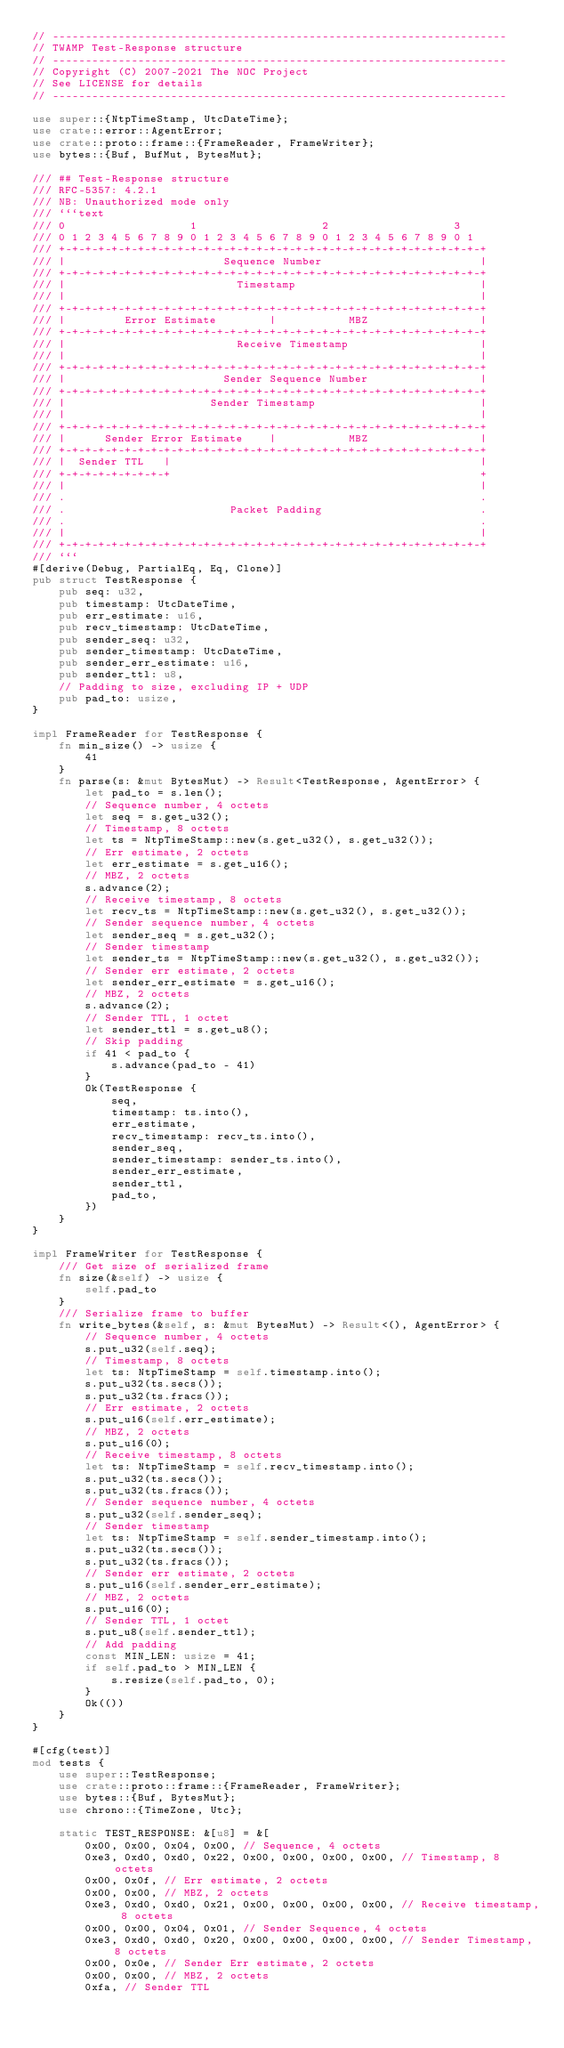Convert code to text. <code><loc_0><loc_0><loc_500><loc_500><_Rust_>// ---------------------------------------------------------------------
// TWAMP Test-Response structure
// ---------------------------------------------------------------------
// Copyright (C) 2007-2021 The NOC Project
// See LICENSE for details
// ---------------------------------------------------------------------

use super::{NtpTimeStamp, UtcDateTime};
use crate::error::AgentError;
use crate::proto::frame::{FrameReader, FrameWriter};
use bytes::{Buf, BufMut, BytesMut};

/// ## Test-Response structure
/// RFC-5357: 4.2.1
/// NB: Unauthorized mode only
/// ```text
/// 0                   1                   2                   3
/// 0 1 2 3 4 5 6 7 8 9 0 1 2 3 4 5 6 7 8 9 0 1 2 3 4 5 6 7 8 9 0 1
/// +-+-+-+-+-+-+-+-+-+-+-+-+-+-+-+-+-+-+-+-+-+-+-+-+-+-+-+-+-+-+-+-+
/// |                        Sequence Number                        |
/// +-+-+-+-+-+-+-+-+-+-+-+-+-+-+-+-+-+-+-+-+-+-+-+-+-+-+-+-+-+-+-+-+
/// |                          Timestamp                            |
/// |                                                               |
/// +-+-+-+-+-+-+-+-+-+-+-+-+-+-+-+-+-+-+-+-+-+-+-+-+-+-+-+-+-+-+-+-+
/// |         Error Estimate        |           MBZ                 |
/// +-+-+-+-+-+-+-+-+-+-+-+-+-+-+-+-+-+-+-+-+-+-+-+-+-+-+-+-+-+-+-+-+
/// |                          Receive Timestamp                    |
/// |                                                               |
/// +-+-+-+-+-+-+-+-+-+-+-+-+-+-+-+-+-+-+-+-+-+-+-+-+-+-+-+-+-+-+-+-+
/// |                        Sender Sequence Number                 |
/// +-+-+-+-+-+-+-+-+-+-+-+-+-+-+-+-+-+-+-+-+-+-+-+-+-+-+-+-+-+-+-+-+
/// |                      Sender Timestamp                         |
/// |                                                               |
/// +-+-+-+-+-+-+-+-+-+-+-+-+-+-+-+-+-+-+-+-+-+-+-+-+-+-+-+-+-+-+-+-+
/// |      Sender Error Estimate    |           MBZ                 |
/// +-+-+-+-+-+-+-+-+-+-+-+-+-+-+-+-+-+-+-+-+-+-+-+-+-+-+-+-+-+-+-+-+
/// |  Sender TTL   |                                               |
/// +-+-+-+-+-+-+-+-+                                               +
/// |                                                               |
/// .                                                               .
/// .                         Packet Padding                        .
/// .                                                               .
/// |                                                               |
/// +-+-+-+-+-+-+-+-+-+-+-+-+-+-+-+-+-+-+-+-+-+-+-+-+-+-+-+-+-+-+-+-+
/// ```
#[derive(Debug, PartialEq, Eq, Clone)]
pub struct TestResponse {
    pub seq: u32,
    pub timestamp: UtcDateTime,
    pub err_estimate: u16,
    pub recv_timestamp: UtcDateTime,
    pub sender_seq: u32,
    pub sender_timestamp: UtcDateTime,
    pub sender_err_estimate: u16,
    pub sender_ttl: u8,
    // Padding to size, excluding IP + UDP
    pub pad_to: usize,
}

impl FrameReader for TestResponse {
    fn min_size() -> usize {
        41
    }
    fn parse(s: &mut BytesMut) -> Result<TestResponse, AgentError> {
        let pad_to = s.len();
        // Sequence number, 4 octets
        let seq = s.get_u32();
        // Timestamp, 8 octets
        let ts = NtpTimeStamp::new(s.get_u32(), s.get_u32());
        // Err estimate, 2 octets
        let err_estimate = s.get_u16();
        // MBZ, 2 octets
        s.advance(2);
        // Receive timestamp, 8 octets
        let recv_ts = NtpTimeStamp::new(s.get_u32(), s.get_u32());
        // Sender sequence number, 4 octets
        let sender_seq = s.get_u32();
        // Sender timestamp
        let sender_ts = NtpTimeStamp::new(s.get_u32(), s.get_u32());
        // Sender err estimate, 2 octets
        let sender_err_estimate = s.get_u16();
        // MBZ, 2 octets
        s.advance(2);
        // Sender TTL, 1 octet
        let sender_ttl = s.get_u8();
        // Skip padding
        if 41 < pad_to {
            s.advance(pad_to - 41)
        }
        Ok(TestResponse {
            seq,
            timestamp: ts.into(),
            err_estimate,
            recv_timestamp: recv_ts.into(),
            sender_seq,
            sender_timestamp: sender_ts.into(),
            sender_err_estimate,
            sender_ttl,
            pad_to,
        })
    }
}

impl FrameWriter for TestResponse {
    /// Get size of serialized frame
    fn size(&self) -> usize {
        self.pad_to
    }
    /// Serialize frame to buffer
    fn write_bytes(&self, s: &mut BytesMut) -> Result<(), AgentError> {
        // Sequence number, 4 octets
        s.put_u32(self.seq);
        // Timestamp, 8 octets
        let ts: NtpTimeStamp = self.timestamp.into();
        s.put_u32(ts.secs());
        s.put_u32(ts.fracs());
        // Err estimate, 2 octets
        s.put_u16(self.err_estimate);
        // MBZ, 2 octets
        s.put_u16(0);
        // Receive timestamp, 8 octets
        let ts: NtpTimeStamp = self.recv_timestamp.into();
        s.put_u32(ts.secs());
        s.put_u32(ts.fracs());
        // Sender sequence number, 4 octets
        s.put_u32(self.sender_seq);
        // Sender timestamp
        let ts: NtpTimeStamp = self.sender_timestamp.into();
        s.put_u32(ts.secs());
        s.put_u32(ts.fracs());
        // Sender err estimate, 2 octets
        s.put_u16(self.sender_err_estimate);
        // MBZ, 2 octets
        s.put_u16(0);
        // Sender TTL, 1 octet
        s.put_u8(self.sender_ttl);
        // Add padding
        const MIN_LEN: usize = 41;
        if self.pad_to > MIN_LEN {
            s.resize(self.pad_to, 0);
        }
        Ok(())
    }
}

#[cfg(test)]
mod tests {
    use super::TestResponse;
    use crate::proto::frame::{FrameReader, FrameWriter};
    use bytes::{Buf, BytesMut};
    use chrono::{TimeZone, Utc};

    static TEST_RESPONSE: &[u8] = &[
        0x00, 0x00, 0x04, 0x00, // Sequence, 4 octets
        0xe3, 0xd0, 0xd0, 0x22, 0x00, 0x00, 0x00, 0x00, // Timestamp, 8 octets
        0x00, 0x0f, // Err estimate, 2 octets
        0x00, 0x00, // MBZ, 2 octets
        0xe3, 0xd0, 0xd0, 0x21, 0x00, 0x00, 0x00, 0x00, // Receive timestamp, 8 octets
        0x00, 0x00, 0x04, 0x01, // Sender Sequence, 4 octets
        0xe3, 0xd0, 0xd0, 0x20, 0x00, 0x00, 0x00, 0x00, // Sender Timestamp, 8 octets
        0x00, 0x0e, // Sender Err estimate, 2 octets
        0x00, 0x00, // MBZ, 2 octets
        0xfa, // Sender TTL</code> 